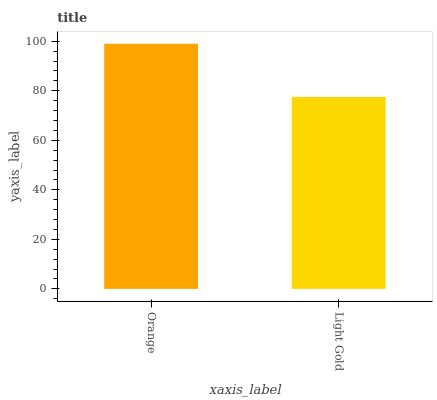Is Light Gold the minimum?
Answer yes or no. Yes. Is Orange the maximum?
Answer yes or no. Yes. Is Light Gold the maximum?
Answer yes or no. No. Is Orange greater than Light Gold?
Answer yes or no. Yes. Is Light Gold less than Orange?
Answer yes or no. Yes. Is Light Gold greater than Orange?
Answer yes or no. No. Is Orange less than Light Gold?
Answer yes or no. No. Is Orange the high median?
Answer yes or no. Yes. Is Light Gold the low median?
Answer yes or no. Yes. Is Light Gold the high median?
Answer yes or no. No. Is Orange the low median?
Answer yes or no. No. 